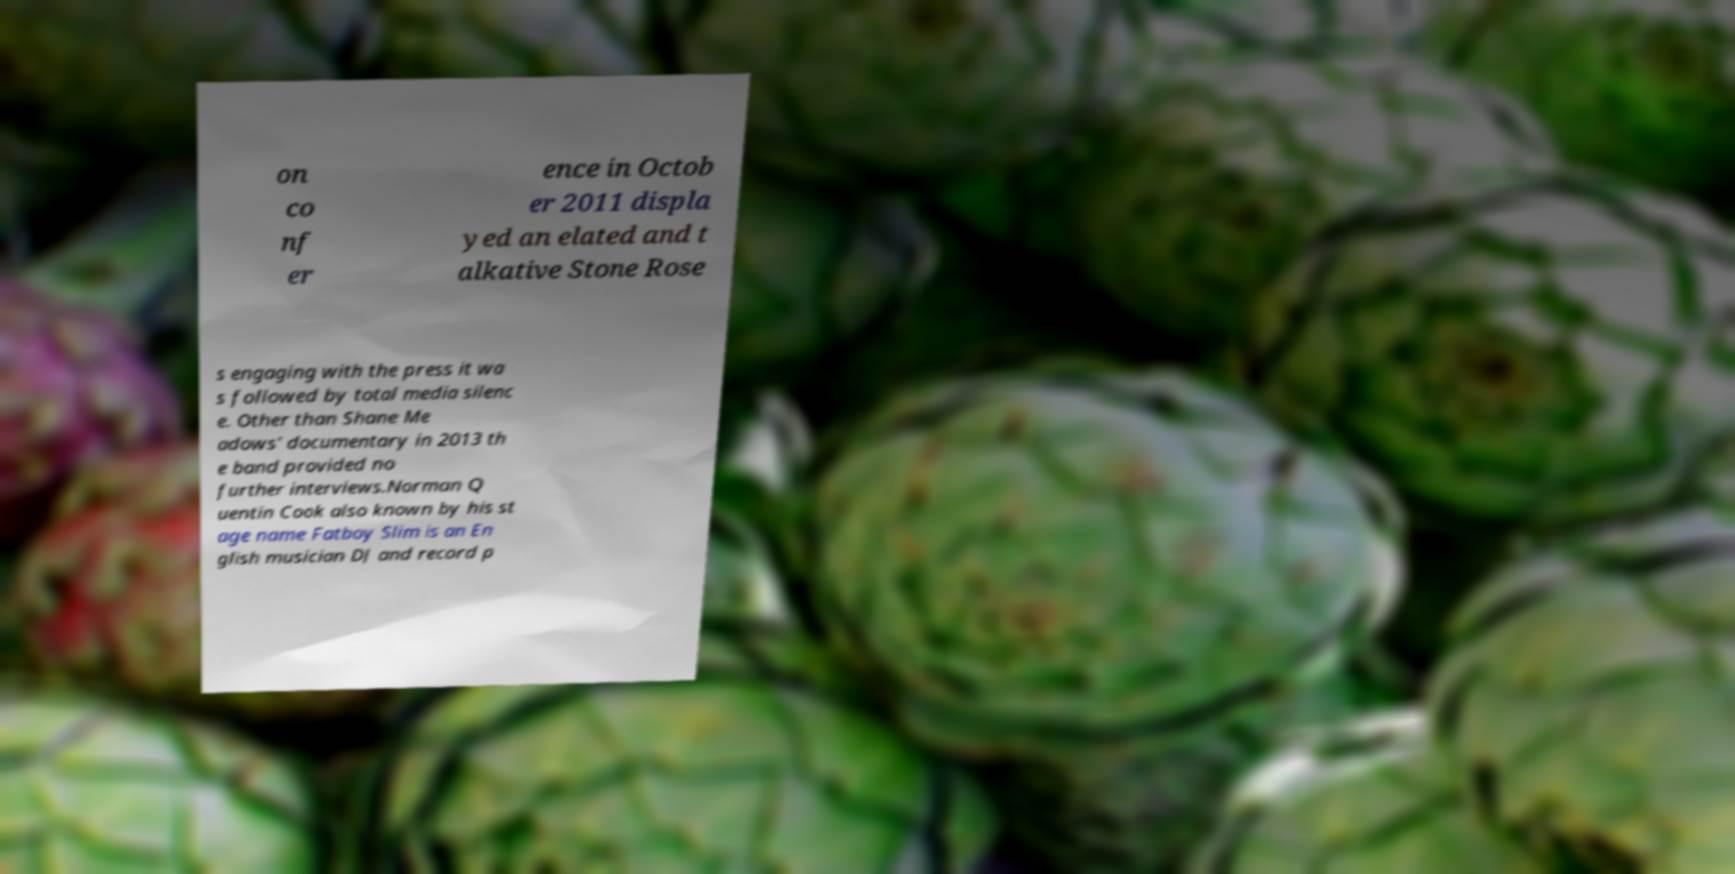Can you accurately transcribe the text from the provided image for me? on co nf er ence in Octob er 2011 displa yed an elated and t alkative Stone Rose s engaging with the press it wa s followed by total media silenc e. Other than Shane Me adows' documentary in 2013 th e band provided no further interviews.Norman Q uentin Cook also known by his st age name Fatboy Slim is an En glish musician DJ and record p 